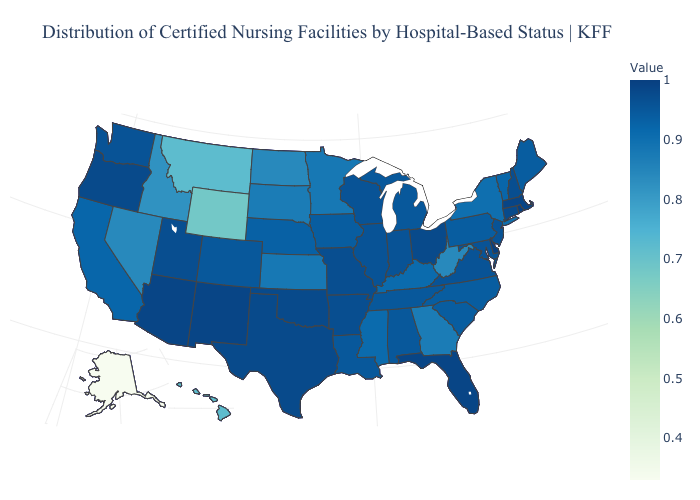Does Delaware have the highest value in the USA?
Concise answer only. Yes. Among the states that border Pennsylvania , which have the lowest value?
Answer briefly. West Virginia. Among the states that border Ohio , does Indiana have the highest value?
Short answer required. Yes. Among the states that border Rhode Island , does Massachusetts have the lowest value?
Give a very brief answer. No. Among the states that border Wisconsin , which have the lowest value?
Give a very brief answer. Minnesota. 